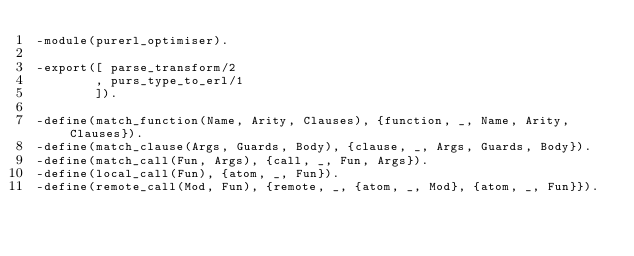Convert code to text. <code><loc_0><loc_0><loc_500><loc_500><_Erlang_>-module(purerl_optimiser).

-export([ parse_transform/2
        , purs_type_to_erl/1
        ]).

-define(match_function(Name, Arity, Clauses), {function, _, Name, Arity, Clauses}).
-define(match_clause(Args, Guards, Body), {clause, _, Args, Guards, Body}).
-define(match_call(Fun, Args), {call, _, Fun, Args}).
-define(local_call(Fun), {atom, _, Fun}).
-define(remote_call(Mod, Fun), {remote, _, {atom, _, Mod}, {atom, _, Fun}}).</code> 